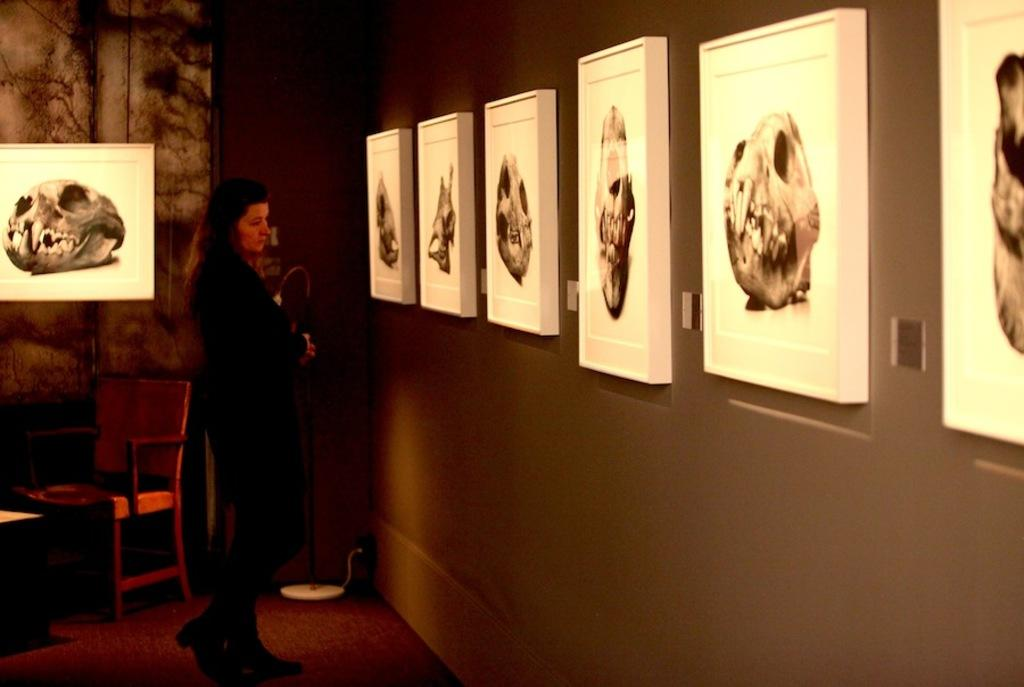Who is present in the image? There is a lady in the image. What can be seen on the right side of the image? There is a wall with pictures on the right side of the image. What is visible in the background of the image? There is a wall with a picture in the background of the image. What type of furniture is near the wall with the picture in the background? There is a chair near the wall with the picture in the background. What type of cough does the lady have in the image? There is no indication of a cough in the image; the lady's health is not mentioned. Is the queen present in the image? There is no mention of a queen in the image; only a lady is present. 